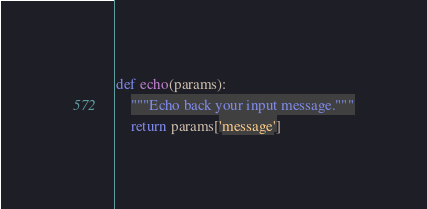Convert code to text. <code><loc_0><loc_0><loc_500><loc_500><_Python_>

def echo(params):
    """Echo back your input message."""
    return params['message']
</code> 